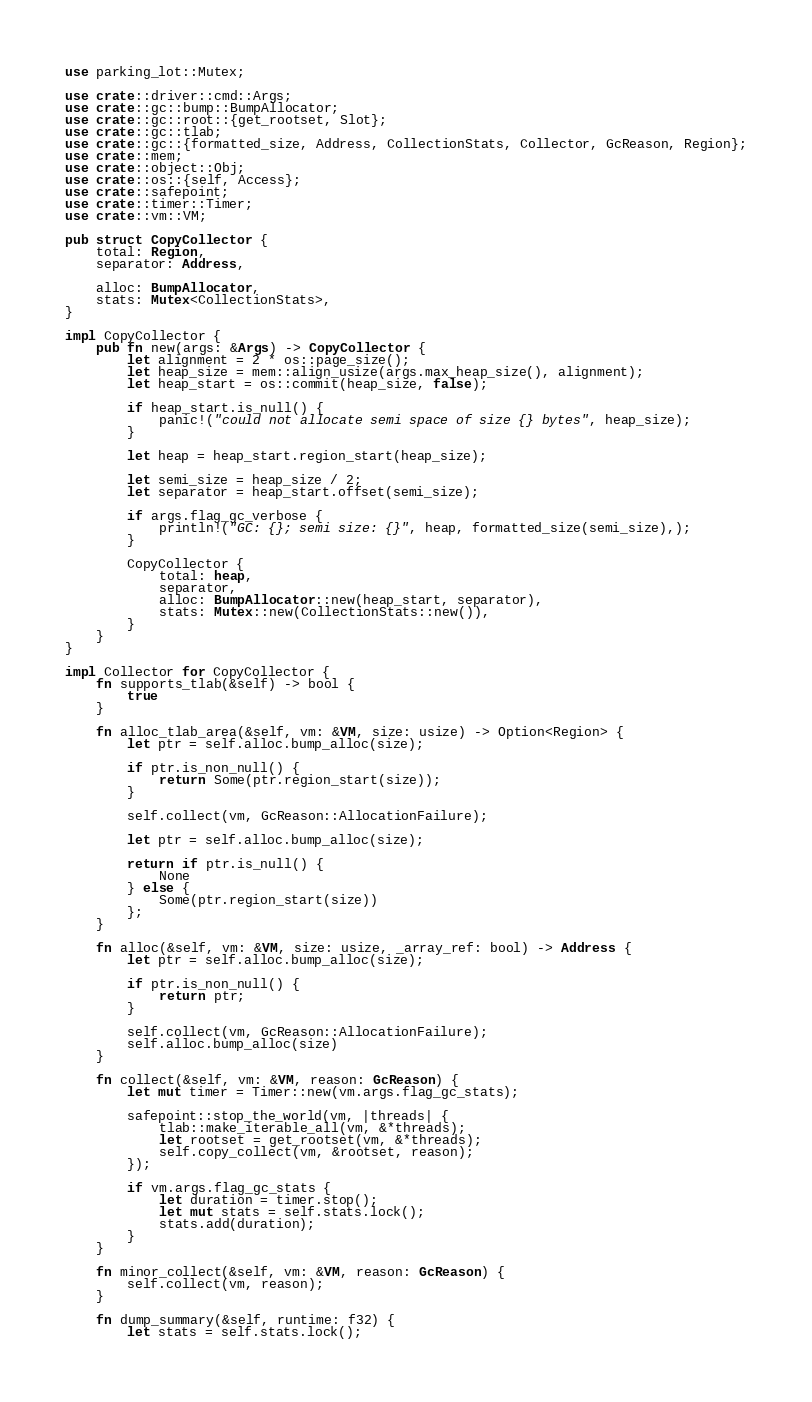<code> <loc_0><loc_0><loc_500><loc_500><_Rust_>use parking_lot::Mutex;

use crate::driver::cmd::Args;
use crate::gc::bump::BumpAllocator;
use crate::gc::root::{get_rootset, Slot};
use crate::gc::tlab;
use crate::gc::{formatted_size, Address, CollectionStats, Collector, GcReason, Region};
use crate::mem;
use crate::object::Obj;
use crate::os::{self, Access};
use crate::safepoint;
use crate::timer::Timer;
use crate::vm::VM;

pub struct CopyCollector {
    total: Region,
    separator: Address,

    alloc: BumpAllocator,
    stats: Mutex<CollectionStats>,
}

impl CopyCollector {
    pub fn new(args: &Args) -> CopyCollector {
        let alignment = 2 * os::page_size();
        let heap_size = mem::align_usize(args.max_heap_size(), alignment);
        let heap_start = os::commit(heap_size, false);

        if heap_start.is_null() {
            panic!("could not allocate semi space of size {} bytes", heap_size);
        }

        let heap = heap_start.region_start(heap_size);

        let semi_size = heap_size / 2;
        let separator = heap_start.offset(semi_size);

        if args.flag_gc_verbose {
            println!("GC: {}; semi size: {}", heap, formatted_size(semi_size),);
        }

        CopyCollector {
            total: heap,
            separator,
            alloc: BumpAllocator::new(heap_start, separator),
            stats: Mutex::new(CollectionStats::new()),
        }
    }
}

impl Collector for CopyCollector {
    fn supports_tlab(&self) -> bool {
        true
    }

    fn alloc_tlab_area(&self, vm: &VM, size: usize) -> Option<Region> {
        let ptr = self.alloc.bump_alloc(size);

        if ptr.is_non_null() {
            return Some(ptr.region_start(size));
        }

        self.collect(vm, GcReason::AllocationFailure);

        let ptr = self.alloc.bump_alloc(size);

        return if ptr.is_null() {
            None
        } else {
            Some(ptr.region_start(size))
        };
    }

    fn alloc(&self, vm: &VM, size: usize, _array_ref: bool) -> Address {
        let ptr = self.alloc.bump_alloc(size);

        if ptr.is_non_null() {
            return ptr;
        }

        self.collect(vm, GcReason::AllocationFailure);
        self.alloc.bump_alloc(size)
    }

    fn collect(&self, vm: &VM, reason: GcReason) {
        let mut timer = Timer::new(vm.args.flag_gc_stats);

        safepoint::stop_the_world(vm, |threads| {
            tlab::make_iterable_all(vm, &*threads);
            let rootset = get_rootset(vm, &*threads);
            self.copy_collect(vm, &rootset, reason);
        });

        if vm.args.flag_gc_stats {
            let duration = timer.stop();
            let mut stats = self.stats.lock();
            stats.add(duration);
        }
    }

    fn minor_collect(&self, vm: &VM, reason: GcReason) {
        self.collect(vm, reason);
    }

    fn dump_summary(&self, runtime: f32) {
        let stats = self.stats.lock();</code> 